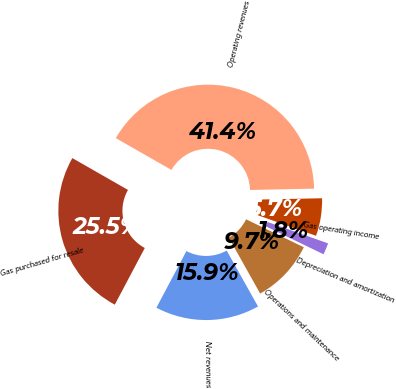<chart> <loc_0><loc_0><loc_500><loc_500><pie_chart><fcel>Operating revenues<fcel>Gas purchased for resale<fcel>Net revenues<fcel>Operations and maintenance<fcel>Depreciation and amortization<fcel>Gas operating income<nl><fcel>41.41%<fcel>25.52%<fcel>15.89%<fcel>9.69%<fcel>1.77%<fcel>5.73%<nl></chart> 